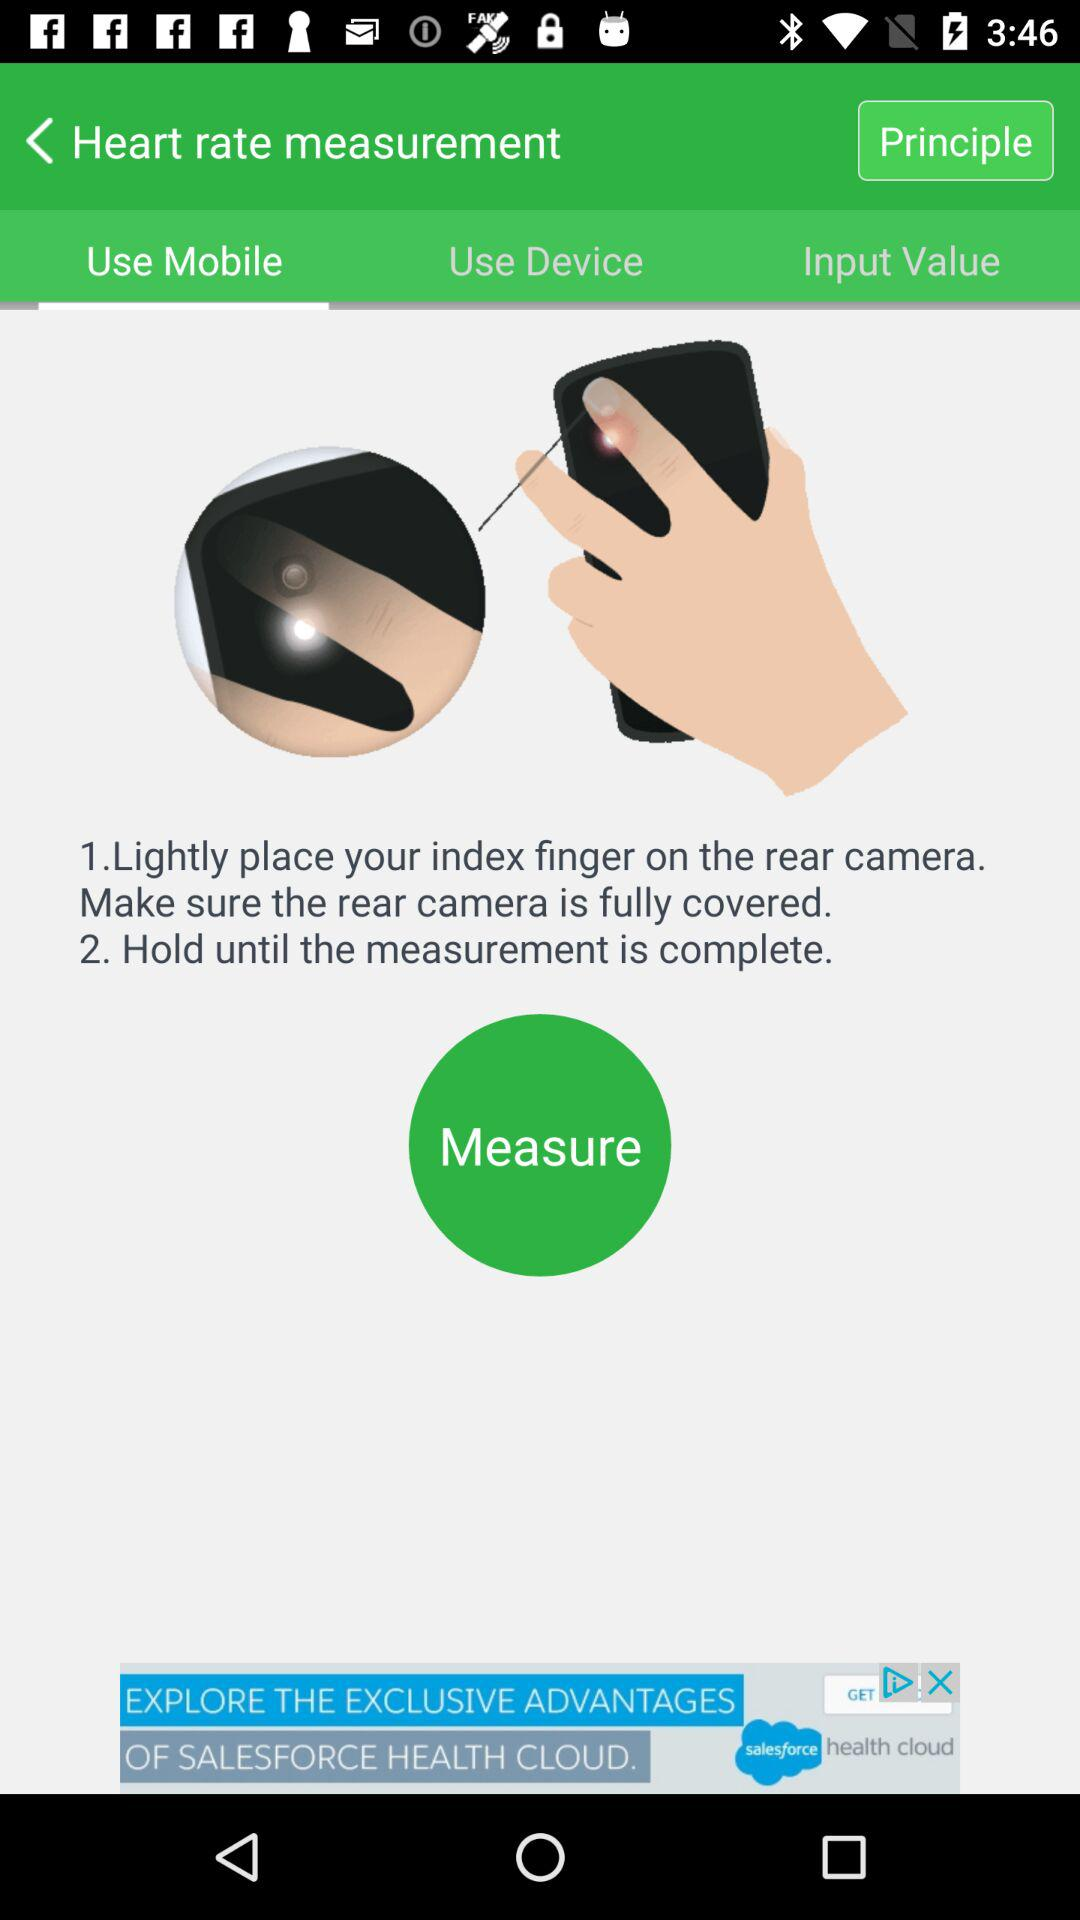How many steps are there in the instructions?
Answer the question using a single word or phrase. 2 